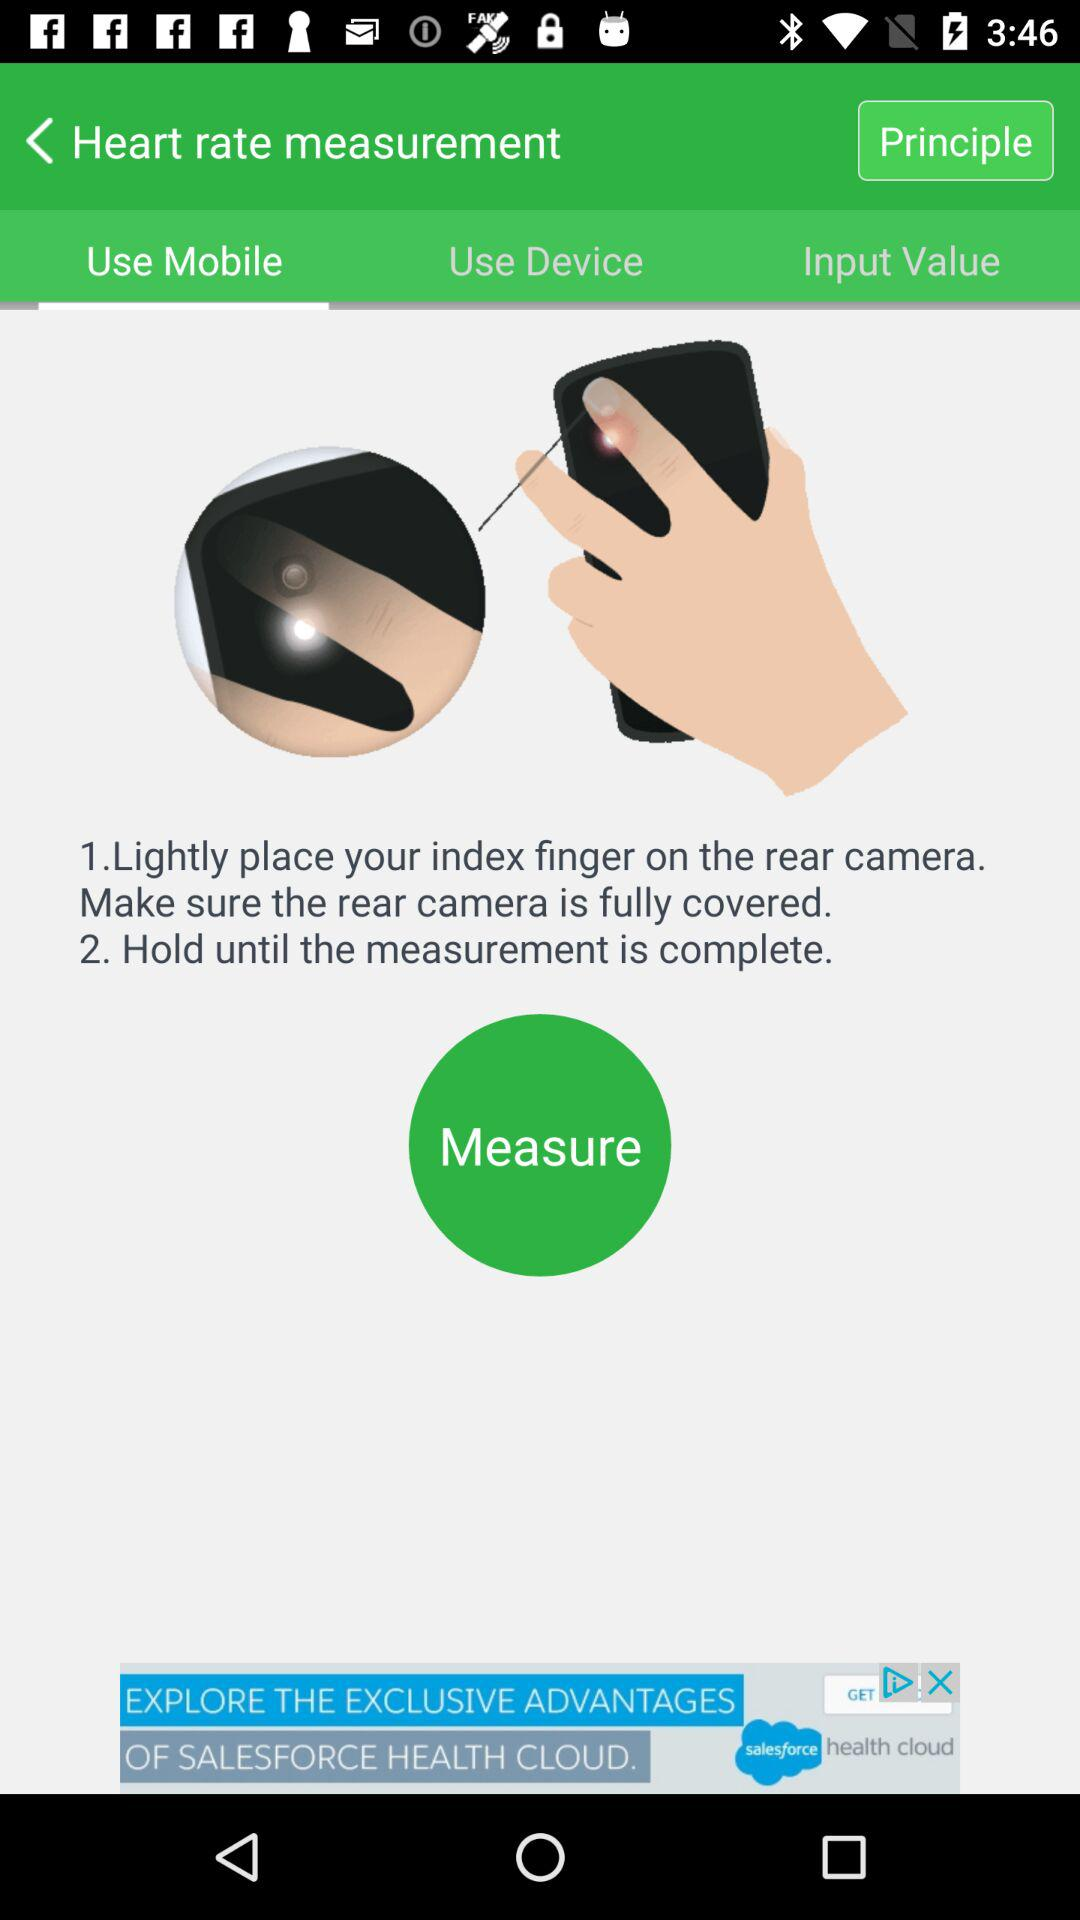How many steps are there in the instructions?
Answer the question using a single word or phrase. 2 